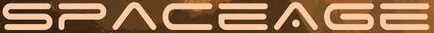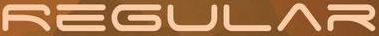Read the text content from these images in order, separated by a semicolon. SPACEAGE; REGULAR 